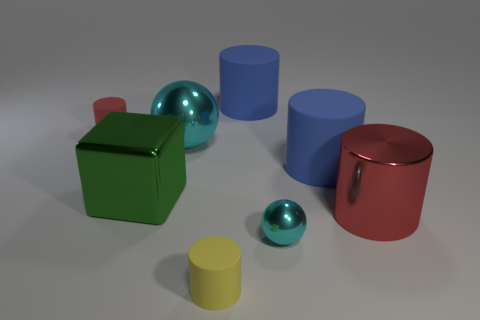Is the big metallic ball the same color as the tiny sphere?
Offer a terse response. Yes. Do the red thing that is left of the tiny sphere and the blue rubber cylinder that is behind the red matte cylinder have the same size?
Ensure brevity in your answer.  No. What is the material of the cyan sphere that is in front of the large matte object that is in front of the large shiny ball?
Give a very brief answer. Metal. The object that is the same color as the big sphere is what shape?
Offer a terse response. Sphere. Is the number of large red metal cylinders that are behind the yellow rubber object greater than the number of blue rubber blocks?
Offer a very short reply. Yes. There is a tiny thing that is on the left side of the small cyan ball and on the right side of the tiny red matte thing; what material is it?
Provide a succinct answer. Rubber. Is there anything else that has the same shape as the big green shiny thing?
Your answer should be very brief. No. What number of big objects are to the right of the tiny cyan metallic sphere and on the left side of the large red shiny cylinder?
Your answer should be very brief. 1. What material is the yellow cylinder?
Make the answer very short. Rubber. Are there the same number of shiny cylinders left of the small red cylinder and small purple objects?
Offer a terse response. Yes. 